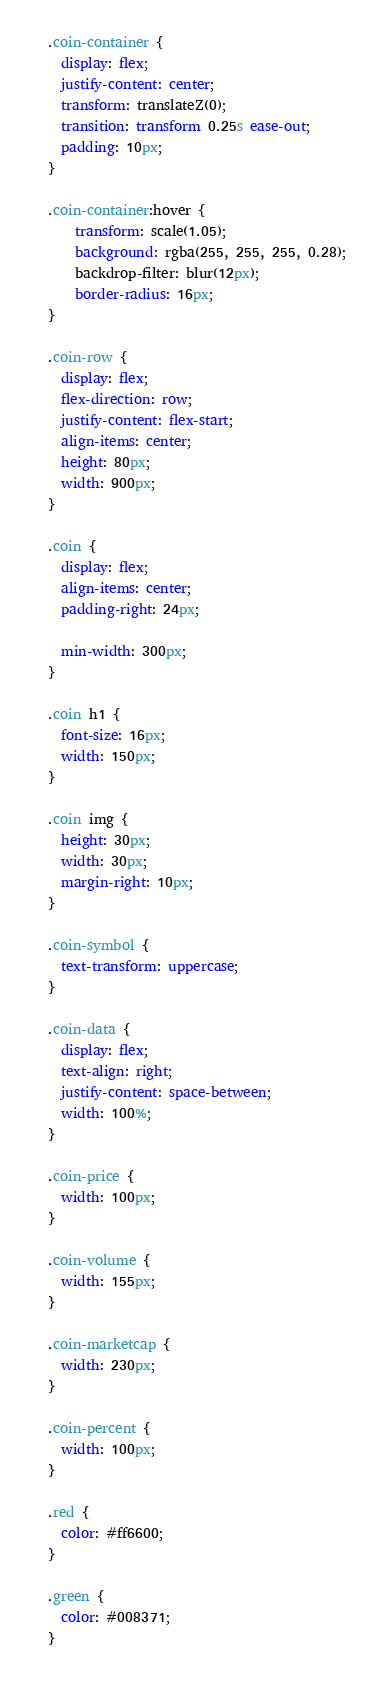Convert code to text. <code><loc_0><loc_0><loc_500><loc_500><_CSS_>  .coin-container {
    display: flex;
    justify-content: center;
    transform: translateZ(0);
    transition: transform 0.25s ease-out;
    padding: 10px;
  }

  .coin-container:hover {
      transform: scale(1.05);
      background: rgba(255, 255, 255, 0.28);
      backdrop-filter: blur(12px);
      border-radius: 16px;
  }

  .coin-row {
    display: flex;
    flex-direction: row;
    justify-content: flex-start;
    align-items: center;
    height: 80px;
    width: 900px;
  }
  
  .coin {
    display: flex;
    align-items: center;
    padding-right: 24px;
  
    min-width: 300px;
  }
  
  .coin h1 {
    font-size: 16px;
    width: 150px;
  }
  
  .coin img {
    height: 30px;
    width: 30px;
    margin-right: 10px;
  }
  
  .coin-symbol {
    text-transform: uppercase;
  }
  
  .coin-data {
    display: flex;
    text-align: right;
    justify-content: space-between;
    width: 100%;
  }
  
  .coin-price {
    width: 100px;
  }
  
  .coin-volume {
    width: 155px;
  }
  
  .coin-marketcap {
    width: 230px;
  }
  
  .coin-percent {
    width: 100px;
  }
  
  .red {
    color: #ff6600;
  }
  
  .green {
    color: #008371;
  }</code> 